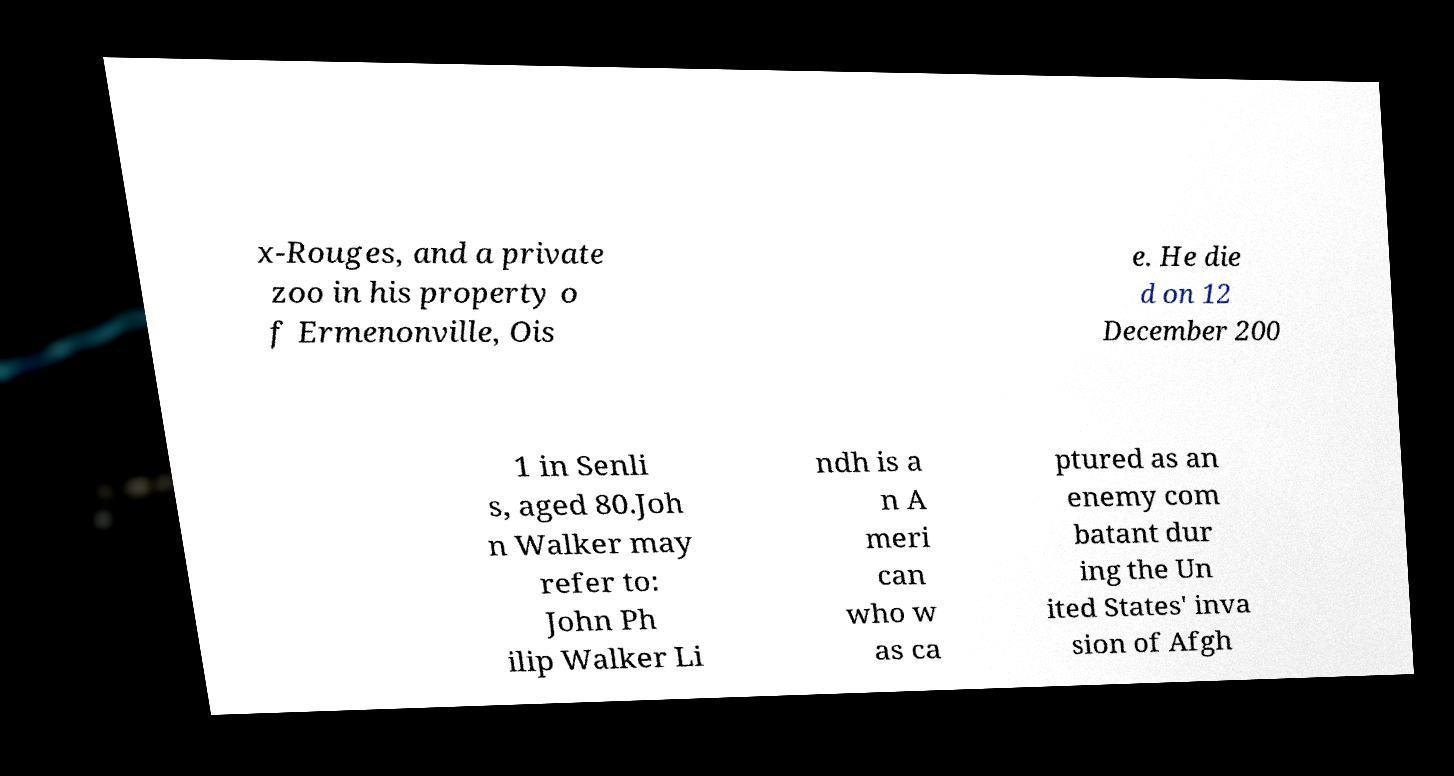I need the written content from this picture converted into text. Can you do that? x-Rouges, and a private zoo in his property o f Ermenonville, Ois e. He die d on 12 December 200 1 in Senli s, aged 80.Joh n Walker may refer to: John Ph ilip Walker Li ndh is a n A meri can who w as ca ptured as an enemy com batant dur ing the Un ited States' inva sion of Afgh 